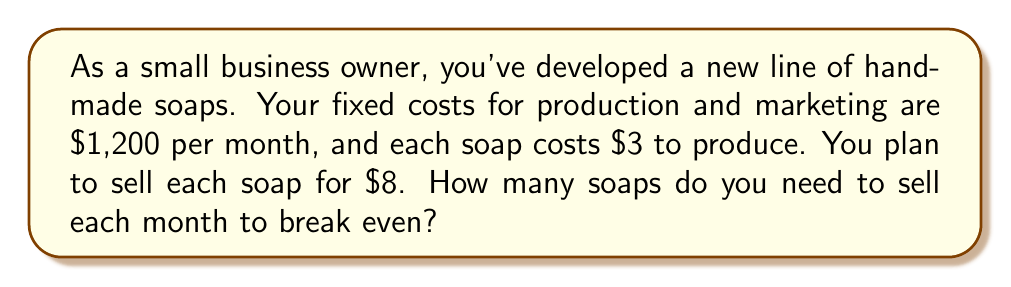Show me your answer to this math problem. Let's approach this step-by-step:

1. Define variables:
   Let $x$ be the number of soaps sold

2. Identify the components:
   - Fixed costs (FC) = $1,200
   - Variable cost per unit (VC) = $3
   - Selling price per unit (P) = $8

3. Set up the break-even equation:
   Revenue = Total Costs
   $Px = FC + VCx$

4. Substitute the values:
   $8x = 1200 + 3x$

5. Solve for x:
   $8x - 3x = 1200$
   $5x = 1200$

6. Divide both sides by 5:
   $x = \frac{1200}{5} = 240$

7. Since we can't sell a fraction of a soap, we round up to the nearest whole number.

Therefore, you need to sell 240 soaps to break even.
Answer: 240 soaps 